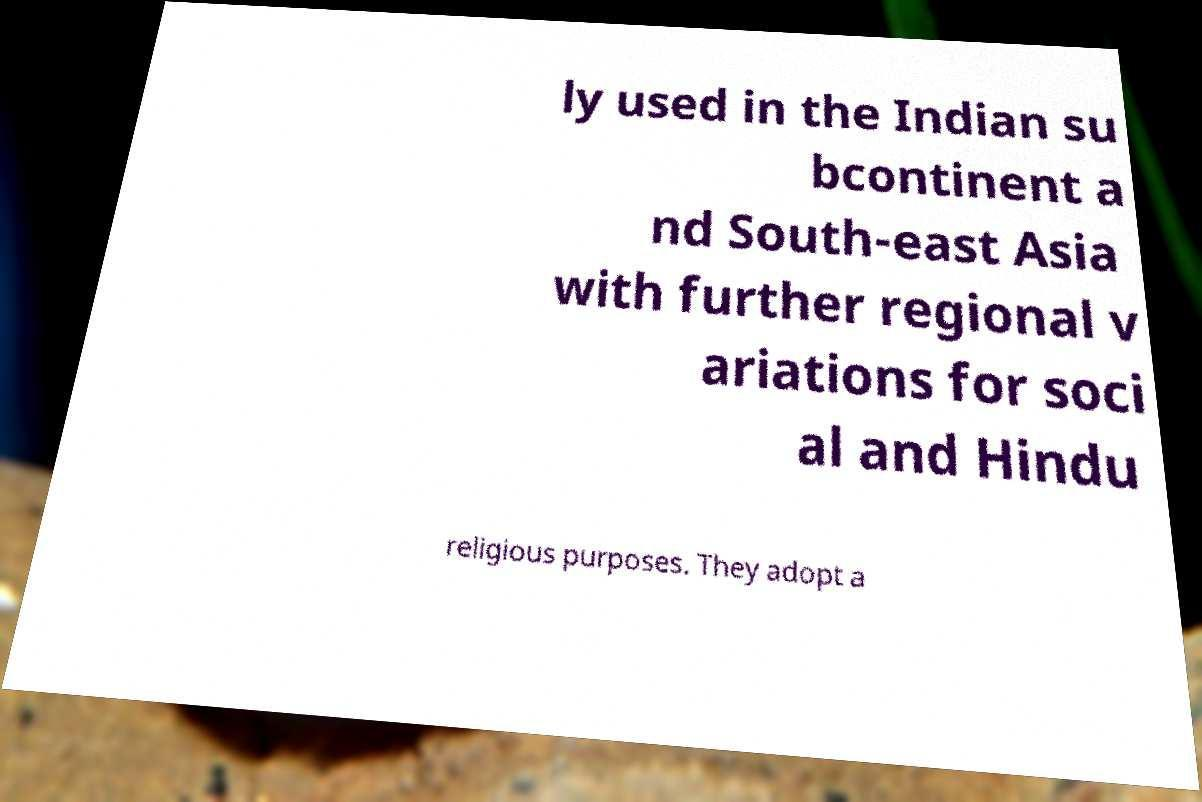Could you extract and type out the text from this image? ly used in the Indian su bcontinent a nd South-east Asia with further regional v ariations for soci al and Hindu religious purposes. They adopt a 